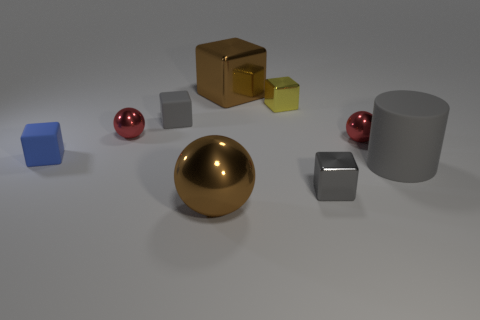Subtract 2 cubes. How many cubes are left? 3 Subtract all yellow cubes. How many cubes are left? 4 Subtract all tiny yellow metallic blocks. How many blocks are left? 4 Add 1 red metal objects. How many objects exist? 10 Subtract all yellow cubes. Subtract all purple cylinders. How many cubes are left? 4 Subtract all cylinders. How many objects are left? 8 Subtract all small gray metal cubes. Subtract all brown cubes. How many objects are left? 7 Add 1 large gray rubber things. How many large gray rubber things are left? 2 Add 7 tiny red balls. How many tiny red balls exist? 9 Subtract 2 red balls. How many objects are left? 7 